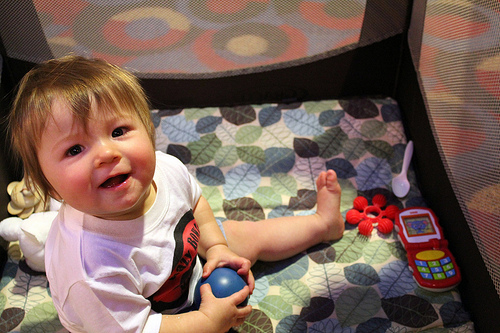<image>
Is the baby on the table? Yes. Looking at the image, I can see the baby is positioned on top of the table, with the table providing support. Is there a baby on the floor? No. The baby is not positioned on the floor. They may be near each other, but the baby is not supported by or resting on top of the floor. 